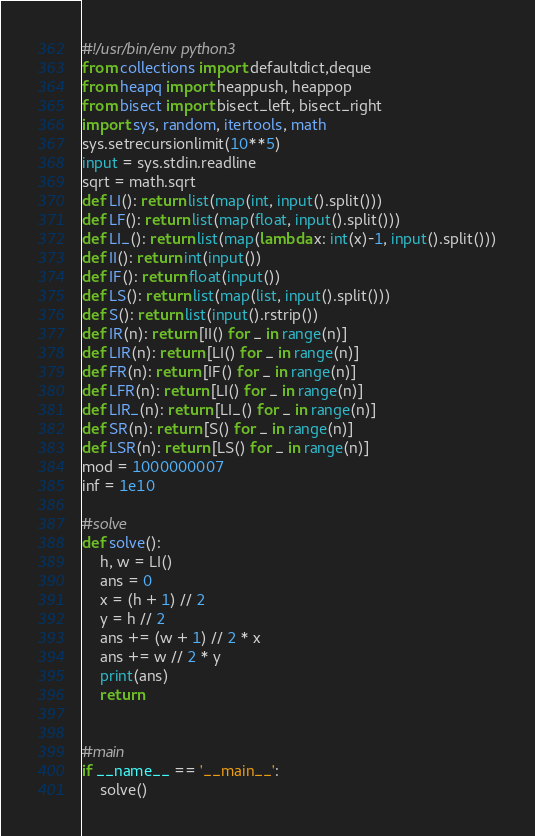<code> <loc_0><loc_0><loc_500><loc_500><_Python_>#!/usr/bin/env python3
from collections import defaultdict,deque
from heapq import heappush, heappop
from bisect import bisect_left, bisect_right
import sys, random, itertools, math
sys.setrecursionlimit(10**5)
input = sys.stdin.readline
sqrt = math.sqrt
def LI(): return list(map(int, input().split()))
def LF(): return list(map(float, input().split()))
def LI_(): return list(map(lambda x: int(x)-1, input().split()))
def II(): return int(input())
def IF(): return float(input())
def LS(): return list(map(list, input().split()))
def S(): return list(input().rstrip())
def IR(n): return [II() for _ in range(n)]
def LIR(n): return [LI() for _ in range(n)]
def FR(n): return [IF() for _ in range(n)]
def LFR(n): return [LI() for _ in range(n)]
def LIR_(n): return [LI_() for _ in range(n)]
def SR(n): return [S() for _ in range(n)]
def LSR(n): return [LS() for _ in range(n)]
mod = 1000000007
inf = 1e10

#solve
def solve():
    h, w = LI()
    ans = 0
    x = (h + 1) // 2
    y = h // 2
    ans += (w + 1) // 2 * x
    ans += w // 2 * y
    print(ans)
    return


#main
if __name__ == '__main__':
    solve()
</code> 